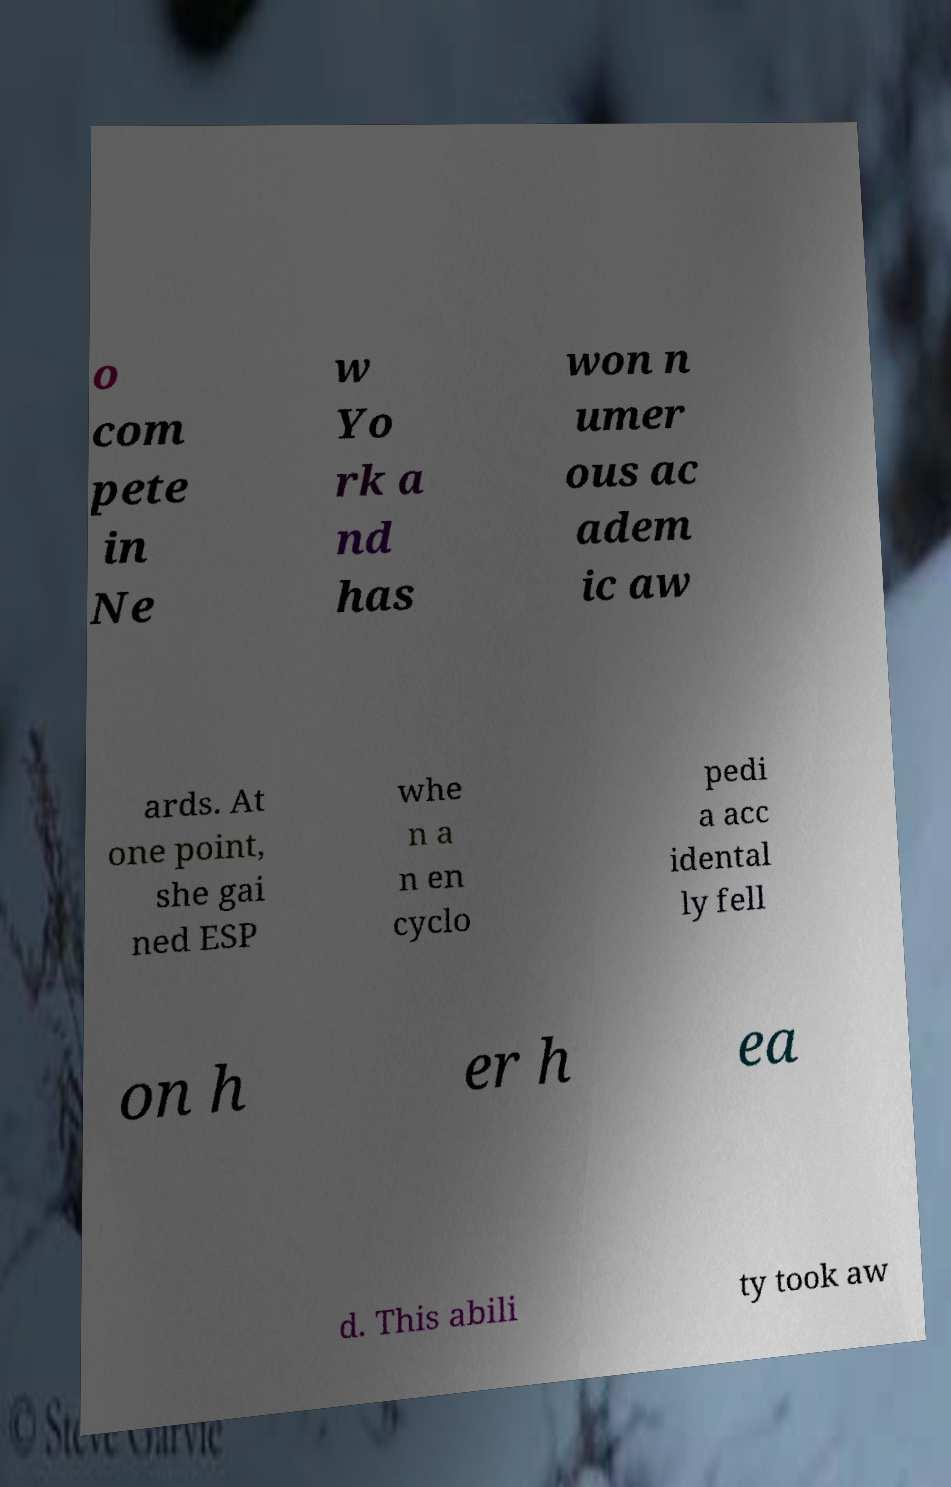Could you assist in decoding the text presented in this image and type it out clearly? o com pete in Ne w Yo rk a nd has won n umer ous ac adem ic aw ards. At one point, she gai ned ESP whe n a n en cyclo pedi a acc idental ly fell on h er h ea d. This abili ty took aw 